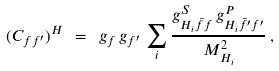<formula> <loc_0><loc_0><loc_500><loc_500>( C _ { f f ^ { \prime } } ) ^ { H } \ = \ g _ { f } \, g _ { f ^ { \prime } } \, \sum _ { i } \frac { g ^ { S } _ { H _ { i } \bar { f } f } \, g ^ { P } _ { H _ { i } \bar { f ^ { \prime } } f ^ { \prime } } } { M _ { H _ { i } } ^ { 2 } } \, ,</formula> 